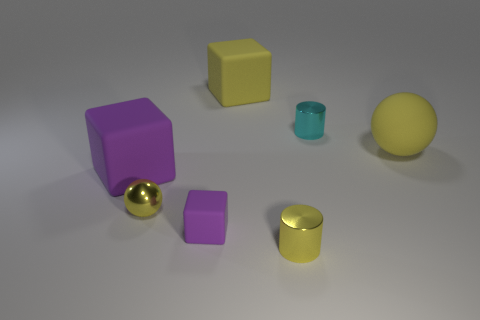What material is the tiny ball in front of the big yellow matte block behind the cyan cylinder?
Make the answer very short. Metal. There is a big purple thing; does it have the same shape as the large yellow thing that is behind the yellow matte sphere?
Your answer should be very brief. Yes. What material is the other purple thing that is the same shape as the small rubber thing?
Keep it short and to the point. Rubber. What is the material of the thing that is right of the small purple thing and in front of the tiny metallic sphere?
Provide a succinct answer. Metal. What is the color of the small cube?
Ensure brevity in your answer.  Purple. Is the number of small things left of the cyan shiny cylinder greater than the number of red matte spheres?
Provide a short and direct response. Yes. What number of purple matte things are in front of the large purple rubber thing?
Your response must be concise. 1. The metallic thing that is the same color as the metal sphere is what shape?
Provide a succinct answer. Cylinder. There is a tiny thing that is on the right side of the tiny yellow object that is in front of the yellow shiny ball; are there any tiny cyan metal things that are behind it?
Ensure brevity in your answer.  No. Is the size of the matte ball the same as the yellow cylinder?
Make the answer very short. No. 